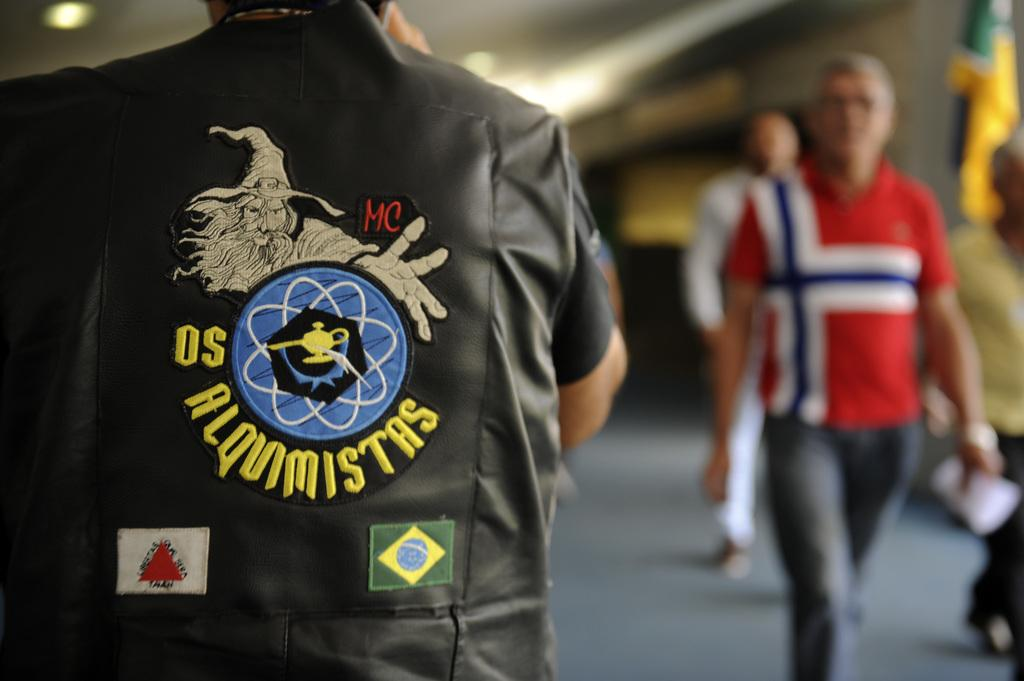Provide a one-sentence caption for the provided image. a man in a jacket with the letters OS on it. 